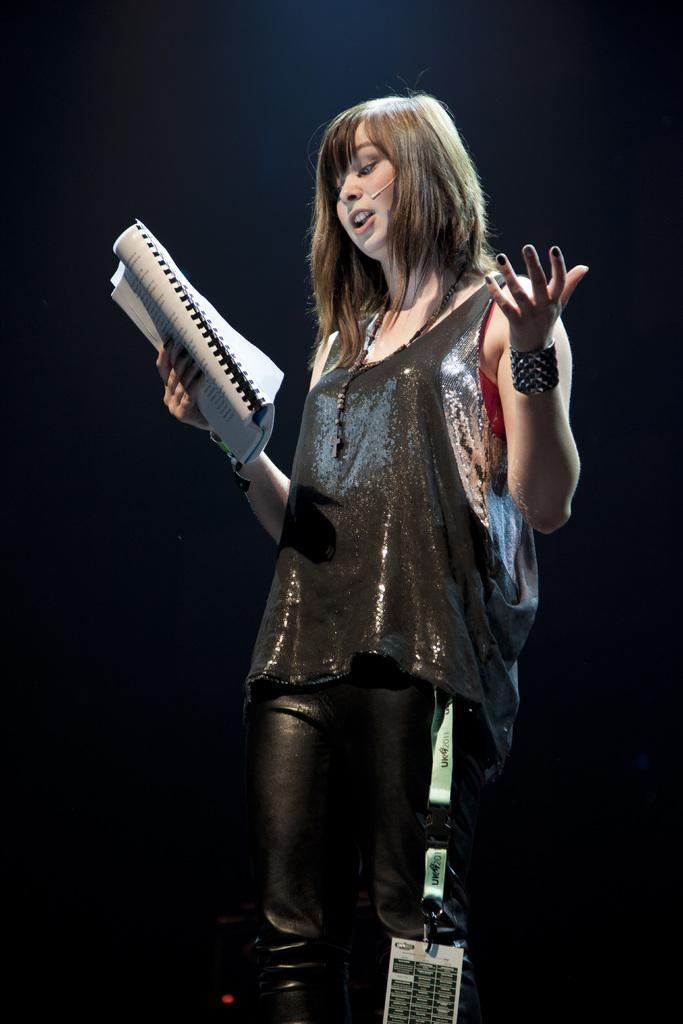What is the main subject of the image? There is a woman in the image. What is the woman holding in her hand? The woman is holding a book in her hand. Can you describe the background of the image? The background of the image is blurry. What shape is the payment method used by the woman in the image? There is no payment method visible in the image, as the woman is holding a book. 